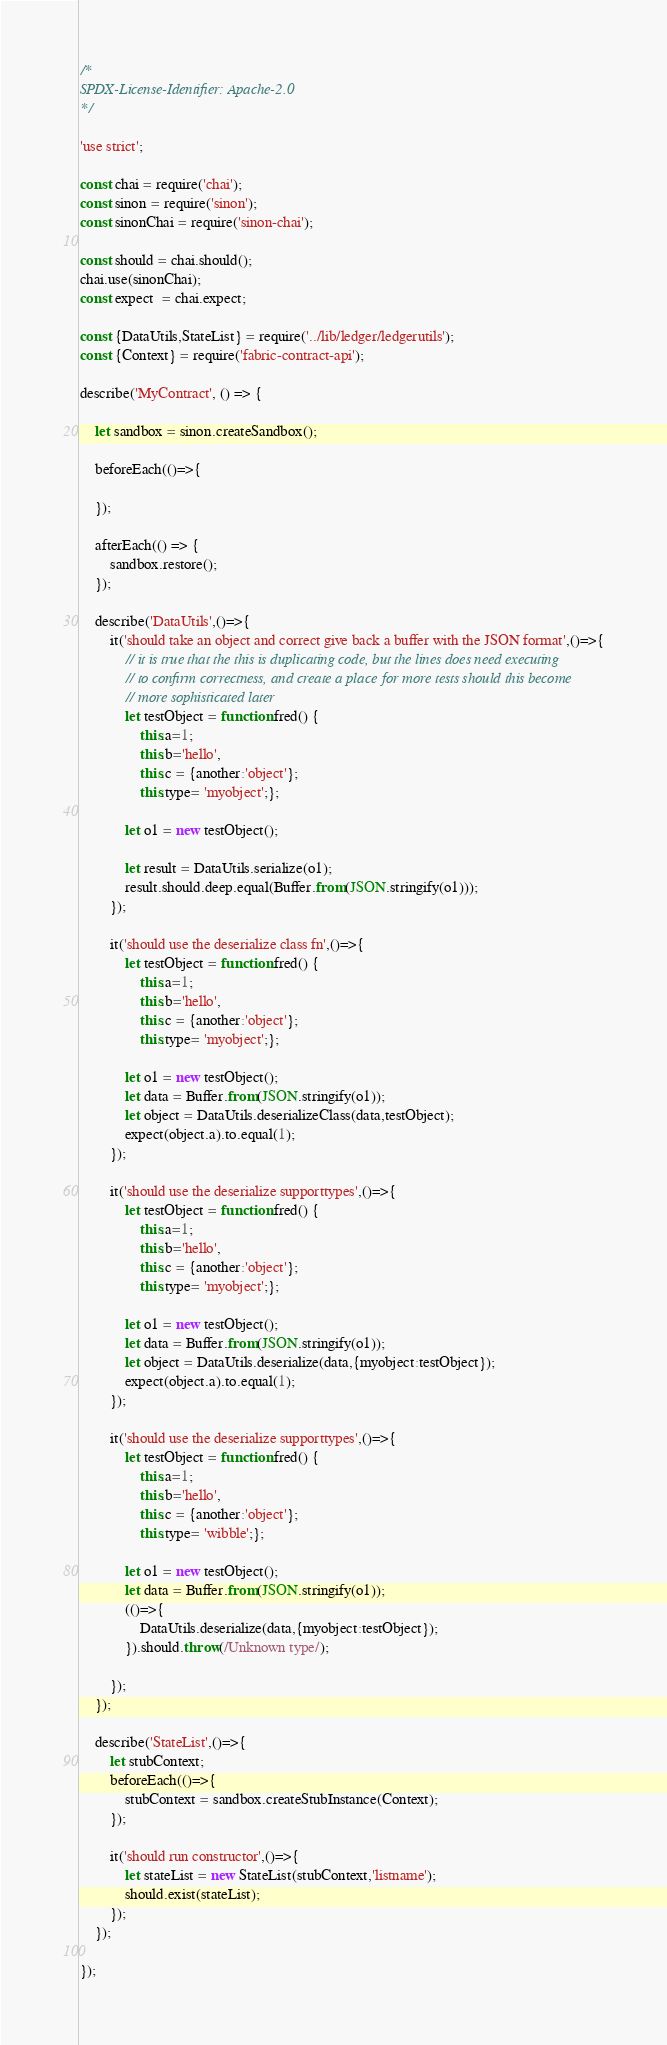<code> <loc_0><loc_0><loc_500><loc_500><_JavaScript_>/*
SPDX-License-Identifier: Apache-2.0
*/

'use strict';

const chai = require('chai');
const sinon = require('sinon');
const sinonChai = require('sinon-chai');

const should = chai.should();
chai.use(sinonChai);
const expect  = chai.expect;

const {DataUtils,StateList} = require('../lib/ledger/ledgerutils');
const {Context} = require('fabric-contract-api');

describe('MyContract', () => {

    let sandbox = sinon.createSandbox();

    beforeEach(()=>{

    });

    afterEach(() => {
        sandbox.restore();
    });

    describe('DataUtils',()=>{
        it('should take an object and correct give back a buffer with the JSON format',()=>{
            // it is true that the this is duplicating code, but the lines does need executing
            // to confirm correctness, and create a place for more tests should this become
            // more sophisticated later
            let testObject = function fred() {
                this.a=1;
                this.b='hello',
                this.c = {another:'object'};
                this.type= 'myobject';};

            let o1 = new testObject();

            let result = DataUtils.serialize(o1);
            result.should.deep.equal(Buffer.from(JSON.stringify(o1)));
        });

        it('should use the deserialize class fn',()=>{
            let testObject = function fred() {
                this.a=1;
                this.b='hello',
                this.c = {another:'object'};
                this.type= 'myobject';};

            let o1 = new testObject();
            let data = Buffer.from(JSON.stringify(o1));
            let object = DataUtils.deserializeClass(data,testObject);
            expect(object.a).to.equal(1);
        });

        it('should use the deserialize supporttypes',()=>{
            let testObject = function fred() {
                this.a=1;
                this.b='hello',
                this.c = {another:'object'};
                this.type= 'myobject';};

            let o1 = new testObject();
            let data = Buffer.from(JSON.stringify(o1));
            let object = DataUtils.deserialize(data,{myobject:testObject});
            expect(object.a).to.equal(1);
        });

        it('should use the deserialize supporttypes',()=>{
            let testObject = function fred() {
                this.a=1;
                this.b='hello',
                this.c = {another:'object'};
                this.type= 'wibble';};

            let o1 = new testObject();
            let data = Buffer.from(JSON.stringify(o1));
            (()=>{
                DataUtils.deserialize(data,{myobject:testObject});
            }).should.throw(/Unknown type/);

        });
    });

    describe('StateList',()=>{
        let stubContext;
        beforeEach(()=>{
            stubContext = sandbox.createStubInstance(Context);
        });

        it('should run constructor',()=>{
            let stateList = new StateList(stubContext,'listname');
            should.exist(stateList);
        });
    });

});
</code> 